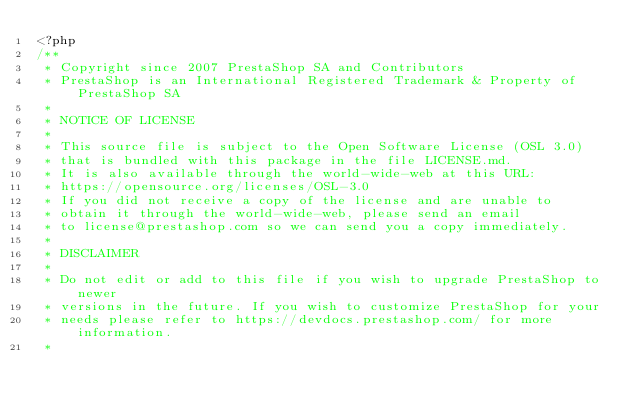Convert code to text. <code><loc_0><loc_0><loc_500><loc_500><_PHP_><?php
/**
 * Copyright since 2007 PrestaShop SA and Contributors
 * PrestaShop is an International Registered Trademark & Property of PrestaShop SA
 *
 * NOTICE OF LICENSE
 *
 * This source file is subject to the Open Software License (OSL 3.0)
 * that is bundled with this package in the file LICENSE.md.
 * It is also available through the world-wide-web at this URL:
 * https://opensource.org/licenses/OSL-3.0
 * If you did not receive a copy of the license and are unable to
 * obtain it through the world-wide-web, please send an email
 * to license@prestashop.com so we can send you a copy immediately.
 *
 * DISCLAIMER
 *
 * Do not edit or add to this file if you wish to upgrade PrestaShop to newer
 * versions in the future. If you wish to customize PrestaShop for your
 * needs please refer to https://devdocs.prestashop.com/ for more information.
 *</code> 